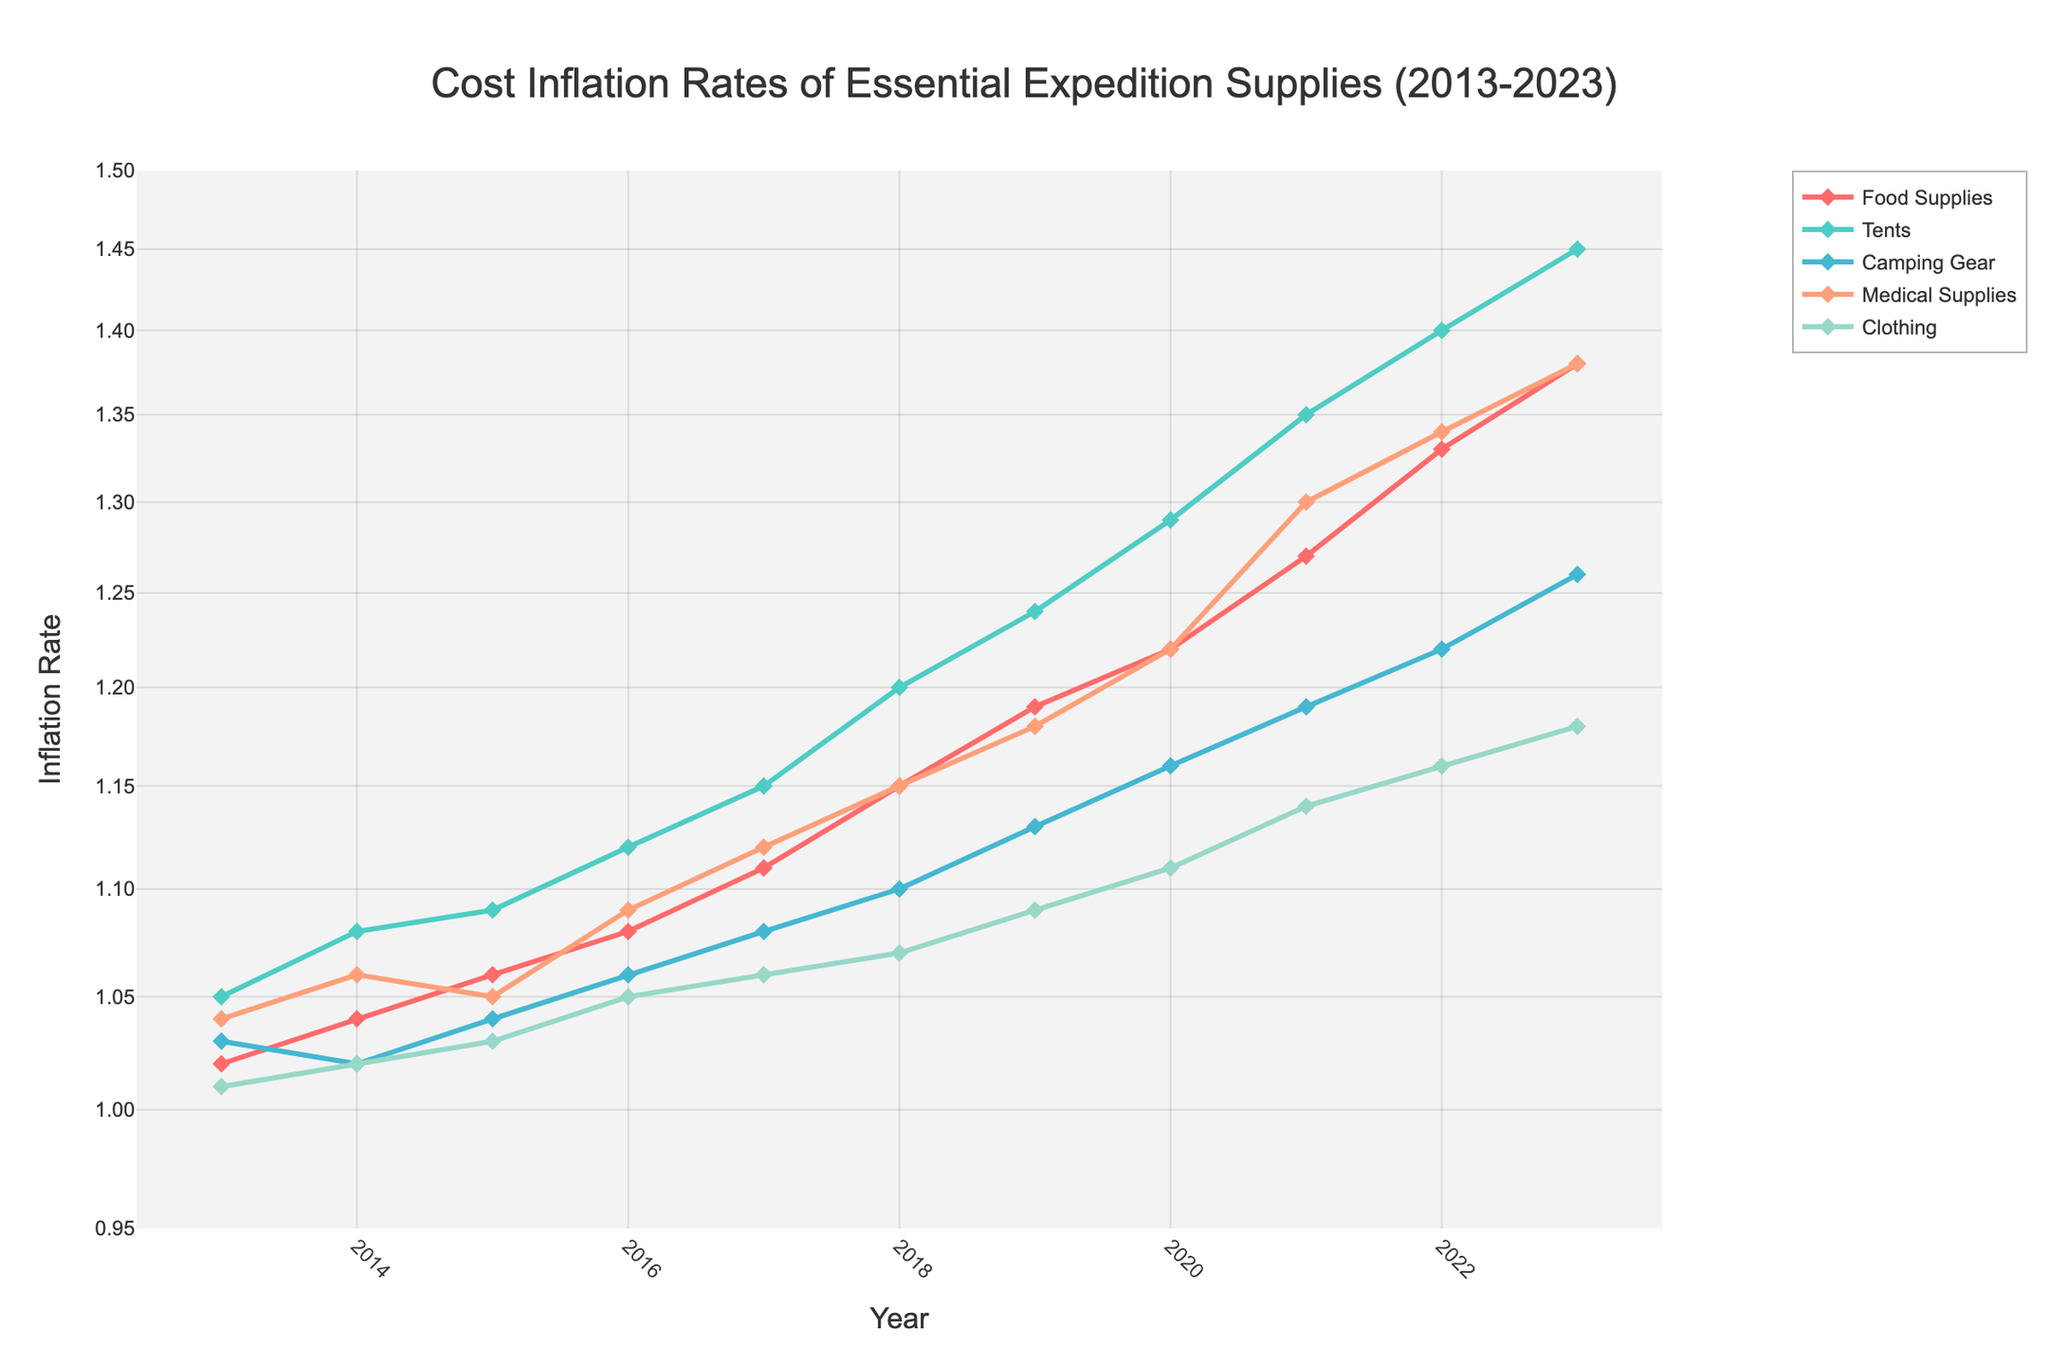What's the title of the plot? The title is generally written at the top center of the plot. Here, it states "Cost Inflation Rates of Essential Expedition Supplies (2013-2023)."
Answer: Cost Inflation Rates of Essential Expedition Supplies (2013-2023) How many supply categories are shown in the figure? The legend indicates the number of supply categories, with each category represented by a different colored line. There are five supply categories.
Answer: Five Which supply category has the highest inflation rate in 2023? By looking at the endpoints of each line for the year 2023, the highest value appears for the "Tents" category.
Answer: Tents What’s the general trend of inflation rates for all supply categories over the decade? Each line slopes upward from left (2013) to right (2023), indicating that inflation rates have generally increased for all supply categories.
Answer: Increasing Which year had the smallest inflation rate for Medical Supplies? By examining the "Medical Supplies" line, the lowest point on the y-axis is in the year 2013.
Answer: 2013 In what year did the inflation rate of Clothing surpass 1.1? Follow the "Clothing" line to the point where it first crosses 1.1 on the y-axis, which happens in 2020.
Answer: 2020 Which supply category experienced the steepest increase in inflation rates between 2017 and 2021? By comparing the slopes of each line between these two years, "Tents" shows the steepest increase.
Answer: Tents What's the difference in the inflation rate between Food Supplies and Medical Supplies in 2020? At the year 2020, the value for Food Supplies is 1.22 and for Medical Supplies is 1.22. The difference is 1.22 - 1.22 = 0.
Answer: 0 Which supply category had the most consistent inflation rate trend over the decade? The most consistent trend would appear as the smoothest and least fluctuating line. "Food Supplies" shows a relatively steady increase.
Answer: Food Supplies What’s the average inflation rate for Camping Gear from 2013 to 2023? Sum the inflation rates from 2013 to 2023 for Camping Gear (1.03, 1.02, 1.04, 1.06, 1.08, 1.1, 1.13, 1.16, 1.19, 1.22, 1.26) and divide by 11. The sum is 11.29, so the average is 11.29 / 11 ≈ 1.026.
Answer: 1.03 